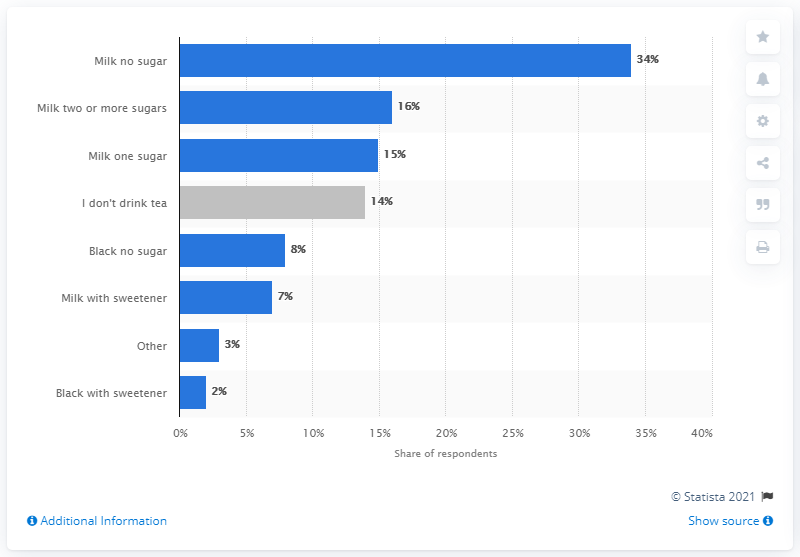Point out several critical features in this image. It is estimated that only 86% of people consume tea on a regular basis, with the remaining 14% choosing not to drink tea. The sum of the top two options is 50. 